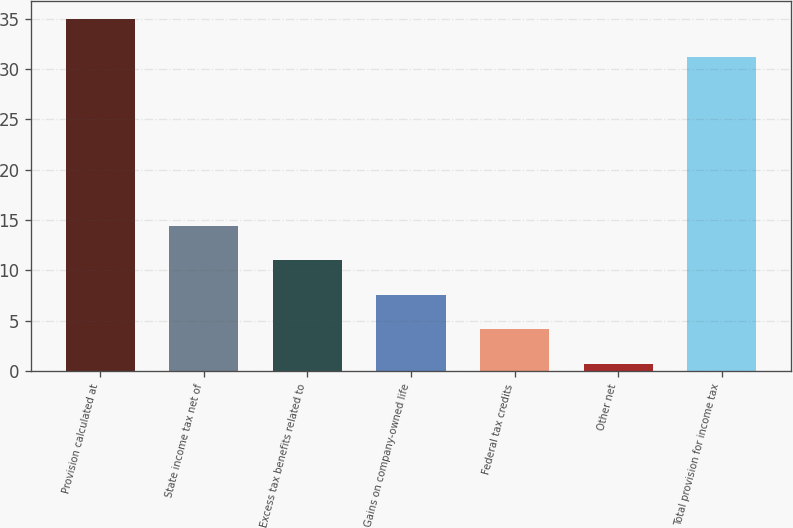<chart> <loc_0><loc_0><loc_500><loc_500><bar_chart><fcel>Provision calculated at<fcel>State income tax net of<fcel>Excess tax benefits related to<fcel>Gains on company-owned life<fcel>Federal tax credits<fcel>Other net<fcel>Total provision for income tax<nl><fcel>35<fcel>14.42<fcel>10.99<fcel>7.56<fcel>4.13<fcel>0.7<fcel>31.2<nl></chart> 